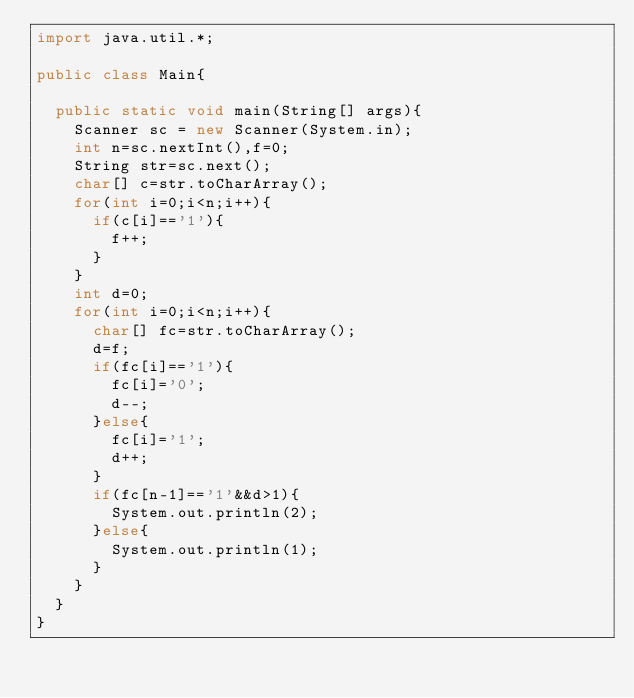Convert code to text. <code><loc_0><loc_0><loc_500><loc_500><_Java_>import java.util.*;

public class Main{
	
  public static void main(String[] args){
    Scanner sc = new Scanner(System.in);
  	int n=sc.nextInt(),f=0;
    String str=sc.next();
    char[] c=str.toCharArray();
    for(int i=0;i<n;i++){
      if(c[i]=='1'){
        f++;
      }
    }
    int d=0;
    for(int i=0;i<n;i++){
      char[] fc=str.toCharArray();
      d=f;
      if(fc[i]=='1'){
        fc[i]='0';
        d--;
      }else{
        fc[i]='1';
        d++;
      }
      if(fc[n-1]=='1'&&d>1){
        System.out.println(2);
      }else{
        System.out.println(1);
      }
    }
  }
}
</code> 